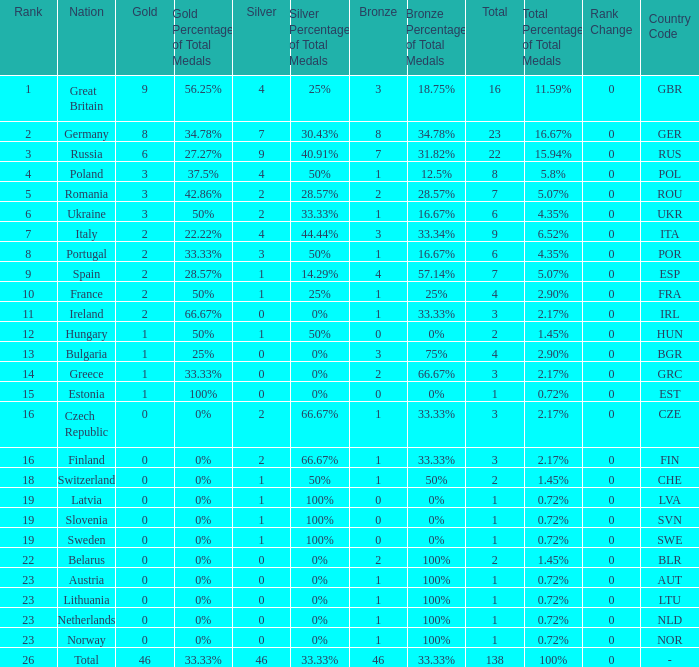What is the total number for a total when the nation is netherlands and silver is larger than 0? 0.0. 